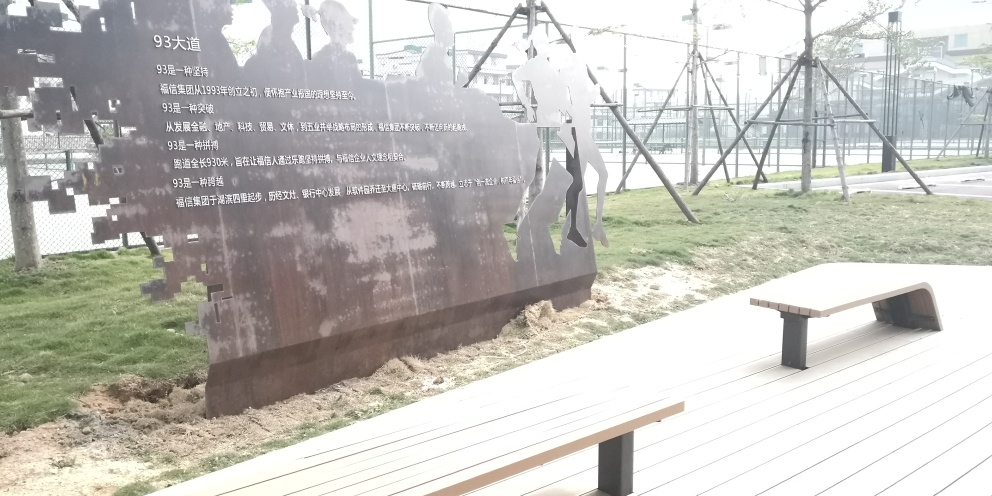Is this photo taken in a public or private space? This photo seems to be taken in a public space, possibly a park or an open-air museum. The inclusion of the bench for seating and the open access to the metal figures suggest that it's an area intended for public use and for people to enjoy the installation. 